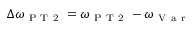Convert formula to latex. <formula><loc_0><loc_0><loc_500><loc_500>\Delta \omega _ { P T 2 } = \omega _ { P T 2 } - \omega _ { V a r }</formula> 